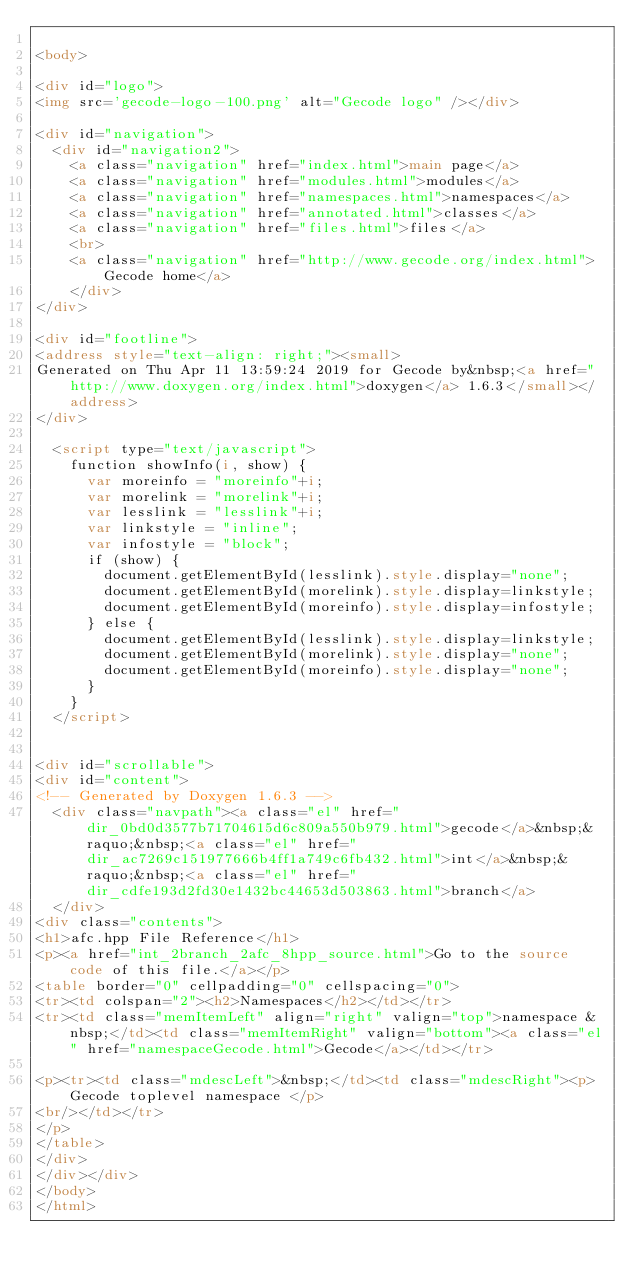Convert code to text. <code><loc_0><loc_0><loc_500><loc_500><_HTML_>
<body>

<div id="logo">
<img src='gecode-logo-100.png' alt="Gecode logo" /></div>

<div id="navigation">
  <div id="navigation2">
    <a class="navigation" href="index.html">main page</a>
    <a class="navigation" href="modules.html">modules</a>
    <a class="navigation" href="namespaces.html">namespaces</a>
    <a class="navigation" href="annotated.html">classes</a>
    <a class="navigation" href="files.html">files</a>
    <br>
    <a class="navigation" href="http://www.gecode.org/index.html">Gecode home</a>
    </div>
</div>

<div id="footline">
<address style="text-align: right;"><small>
Generated on Thu Apr 11 13:59:24 2019 for Gecode by&nbsp;<a href="http://www.doxygen.org/index.html">doxygen</a> 1.6.3</small></address>
</div>

  <script type="text/javascript">
    function showInfo(i, show) {
      var moreinfo = "moreinfo"+i;
      var morelink = "morelink"+i;
      var lesslink = "lesslink"+i;
      var linkstyle = "inline";
      var infostyle = "block";
      if (show) {
        document.getElementById(lesslink).style.display="none";
        document.getElementById(morelink).style.display=linkstyle;
        document.getElementById(moreinfo).style.display=infostyle;
      } else {
        document.getElementById(lesslink).style.display=linkstyle;
        document.getElementById(morelink).style.display="none";
        document.getElementById(moreinfo).style.display="none";
      }
    }
  </script>


<div id="scrollable">
<div id="content">
<!-- Generated by Doxygen 1.6.3 -->
  <div class="navpath"><a class="el" href="dir_0bd0d3577b71704615d6c809a550b979.html">gecode</a>&nbsp;&raquo;&nbsp;<a class="el" href="dir_ac7269c151977666b4ff1a749c6fb432.html">int</a>&nbsp;&raquo;&nbsp;<a class="el" href="dir_cdfe193d2fd30e1432bc44653d503863.html">branch</a>
  </div>
<div class="contents">
<h1>afc.hpp File Reference</h1>
<p><a href="int_2branch_2afc_8hpp_source.html">Go to the source code of this file.</a></p>
<table border="0" cellpadding="0" cellspacing="0">
<tr><td colspan="2"><h2>Namespaces</h2></td></tr>
<tr><td class="memItemLeft" align="right" valign="top">namespace &nbsp;</td><td class="memItemRight" valign="bottom"><a class="el" href="namespaceGecode.html">Gecode</a></td></tr>

<p><tr><td class="mdescLeft">&nbsp;</td><td class="mdescRight"><p>Gecode toplevel namespace </p>
<br/></td></tr>
</p>
</table>
</div>
</div></div>
</body>
</html>
</code> 